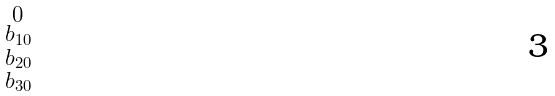Convert formula to latex. <formula><loc_0><loc_0><loc_500><loc_500>\begin{smallmatrix} 0 \\ b _ { 1 0 } \\ b _ { 2 0 } \\ b _ { 3 0 } \\ \end{smallmatrix}</formula> 